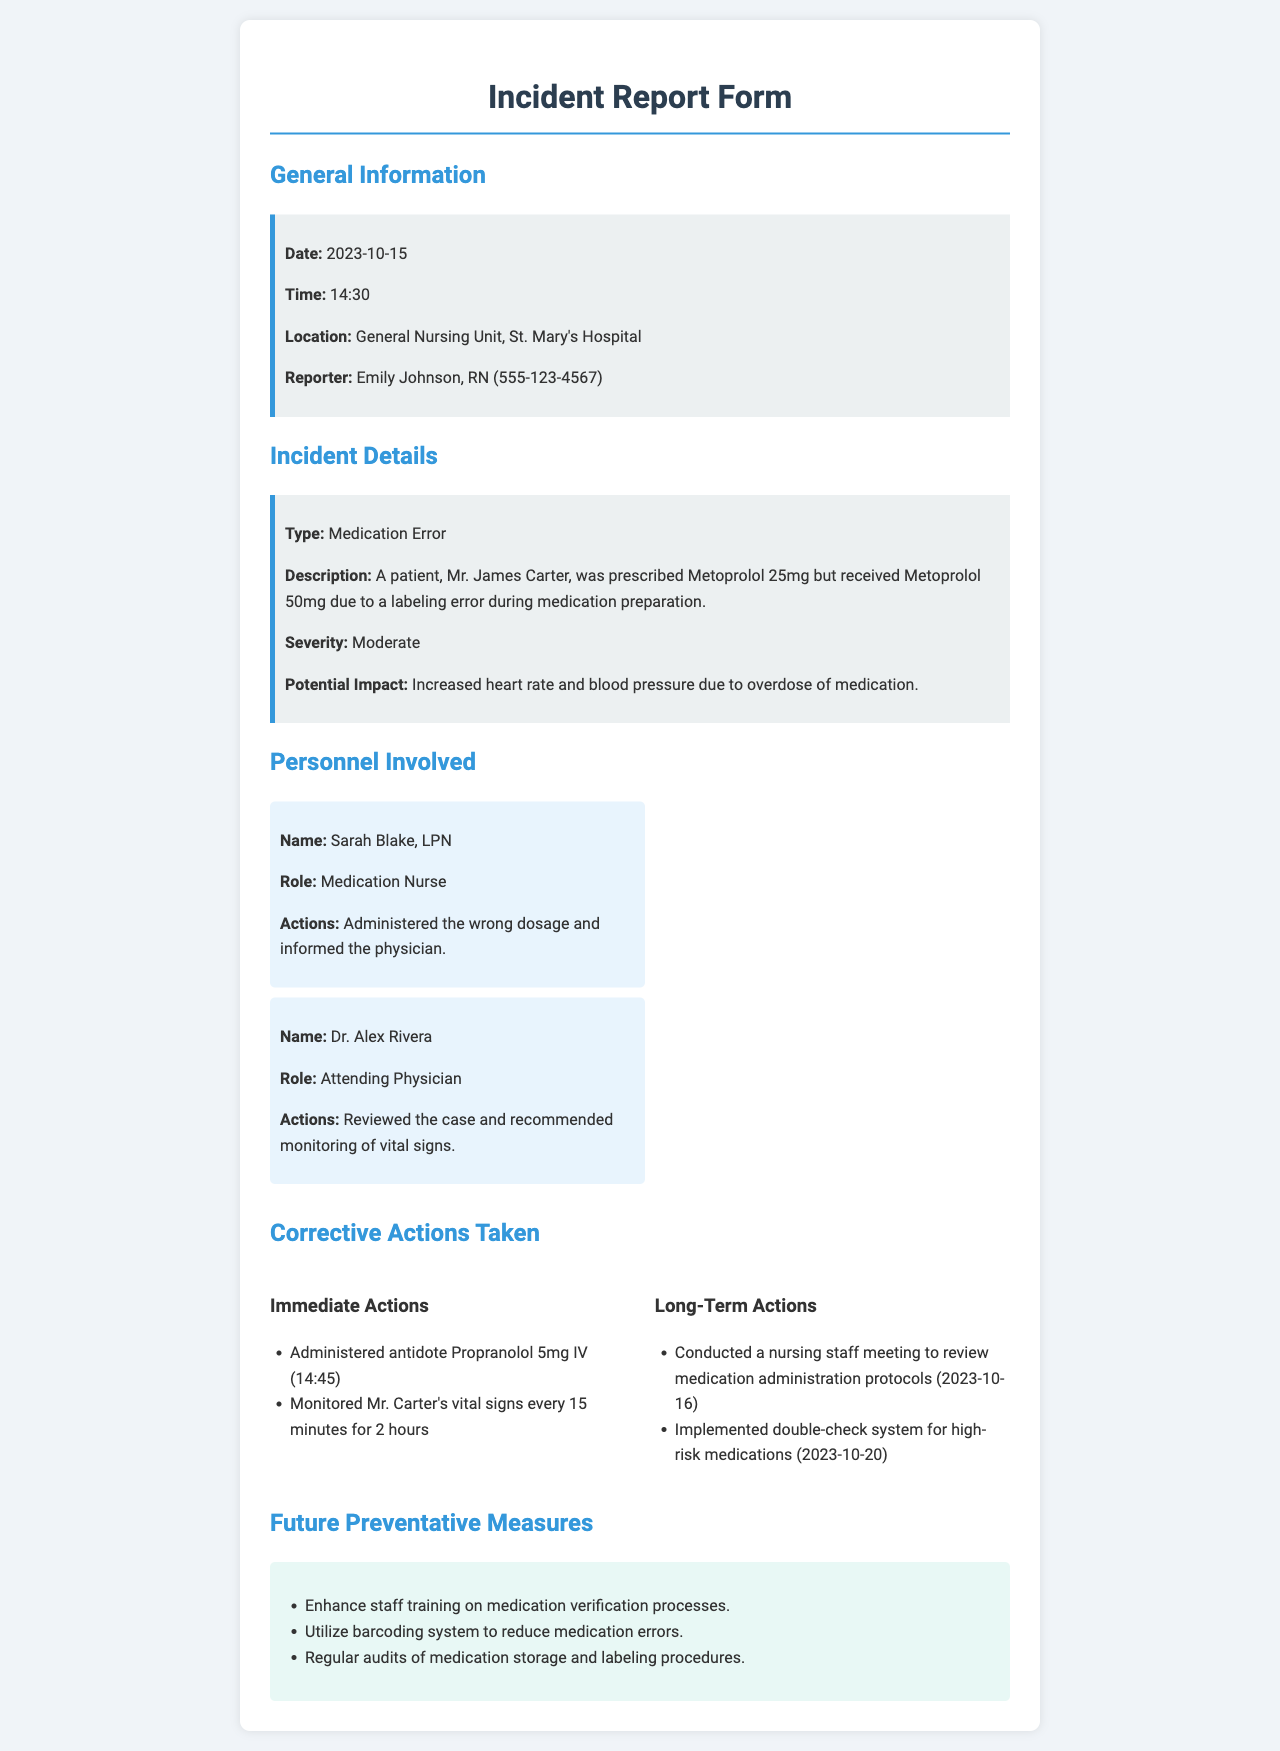what is the date of the incident? The date of the incident is highlighted in the general information section of the report.
Answer: 2023-10-15 what was the type of incident? The type of incident is specified under the incident details section of the report.
Answer: Medication Error who reported the incident? The name of the reporter is listed in the general information section.
Answer: Emily Johnson, RN what time did the incident occur? The time of the incident is indicated in the general information section.
Answer: 14:30 what was administered to Mr. Carter as an immediate action? The immediate action taken is mentioned in the corrective actions section of the report.
Answer: Propranolol 5mg IV how many minutes were Mr. Carter's vital signs monitored after the incident? The duration of monitoring is detailed in the immediate actions of the corrective actions section.
Answer: 2 hours what medication was prescribed to Mr. James Carter? The prescribed medication is indicated in the incident details portion of the report.
Answer: Metoprolol 25mg who was the attending physician involved in the incident? The name of the attending physician is listed under the personnel involved section.
Answer: Dr. Alex Rivera what is one of the future preventative measures listed? The future preventative measures are specified at the end of the report.
Answer: Enhance staff training on medication verification processes 